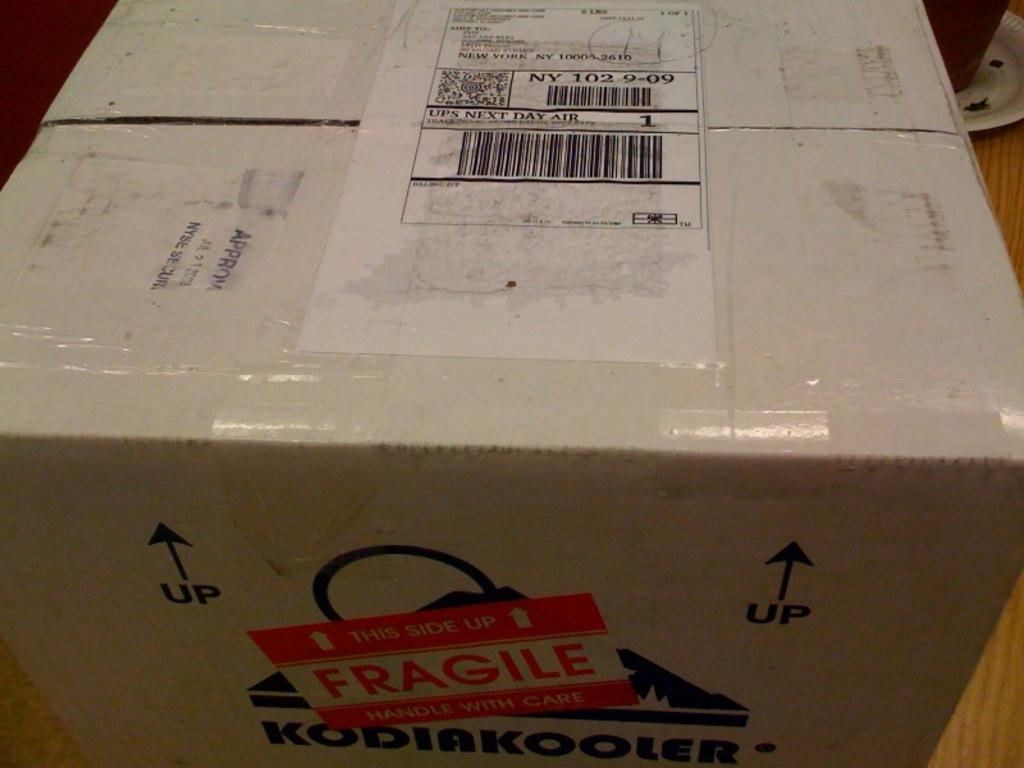Which shipping company was used to send the package?
Give a very brief answer. Ups. Is this box fragile or no?
Ensure brevity in your answer.  Yes. 